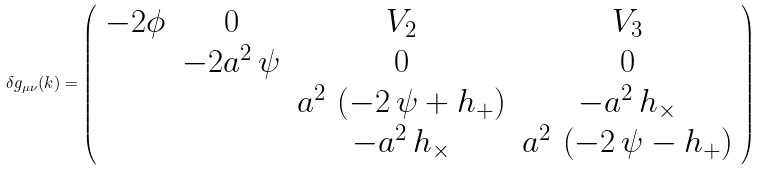Convert formula to latex. <formula><loc_0><loc_0><loc_500><loc_500>\delta g _ { \mu \nu } ( k ) = \left ( \begin{array} { c c c c } - 2 \phi & 0 & V _ { 2 } & V _ { 3 } \\ & - 2 a ^ { 2 } \, \psi & 0 & 0 \\ & & a ^ { 2 } \, \left ( - 2 \, \psi + h _ { + } \right ) & - a ^ { 2 } \, h _ { \times } \\ & & - a ^ { 2 } \, h _ { \times } & a ^ { 2 } \, \left ( - 2 \, \psi - h _ { + } \right ) \end{array} \right )</formula> 